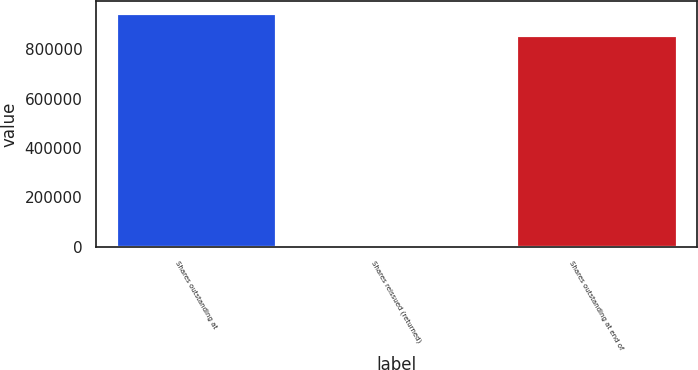<chart> <loc_0><loc_0><loc_500><loc_500><bar_chart><fcel>Shares outstanding at<fcel>Shares reissued (returned)<fcel>Shares outstanding at end of<nl><fcel>947979<fcel>4964<fcel>859403<nl></chart> 